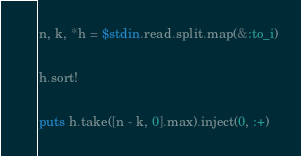<code> <loc_0><loc_0><loc_500><loc_500><_Ruby_>n, k, *h = $stdin.read.split.map(&:to_i)

h.sort!

puts h.take([n - k, 0].max).inject(0, :+)
</code> 